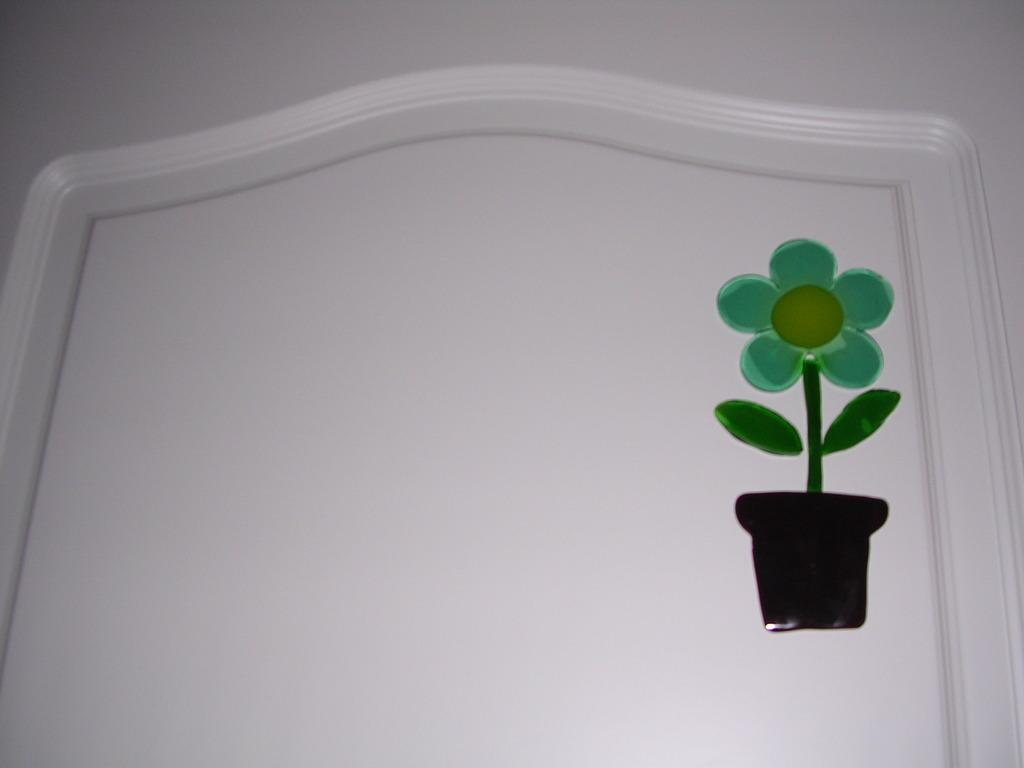What is depicted in the image? There is a picture of a pot in the image. What additional detail can be observed on the pot? The picture of the pot has a flower painted on it. Where is the picture of the pot with the flower located? The picture of the pot with the flower is on a wall. How many cherries are hanging from the flower painted on the pot in the image? There are no cherries present in the image; the flower painted on the pot does not have any cherries. 